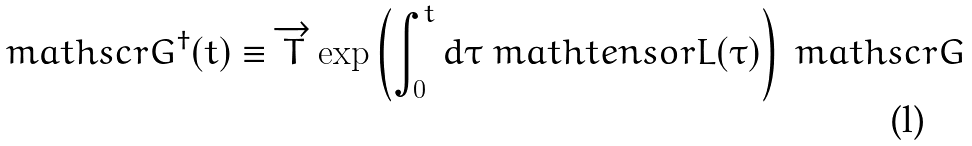<formula> <loc_0><loc_0><loc_500><loc_500>\ m a t h s c r { G } ^ { \dagger } ( t ) \equiv \overrightarrow { T } \exp \left ( \int _ { 0 } ^ { t } d \tau \ m a t h t e n s o r { L } ( \tau ) \right ) \ m a t h s c r { G }</formula> 